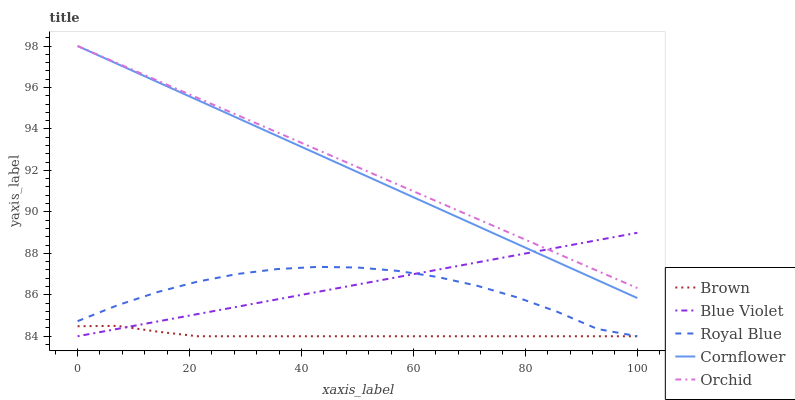Does Brown have the minimum area under the curve?
Answer yes or no. Yes. Does Orchid have the maximum area under the curve?
Answer yes or no. Yes. Does Cornflower have the minimum area under the curve?
Answer yes or no. No. Does Cornflower have the maximum area under the curve?
Answer yes or no. No. Is Blue Violet the smoothest?
Answer yes or no. Yes. Is Royal Blue the roughest?
Answer yes or no. Yes. Is Orchid the smoothest?
Answer yes or no. No. Is Orchid the roughest?
Answer yes or no. No. Does Brown have the lowest value?
Answer yes or no. Yes. Does Cornflower have the lowest value?
Answer yes or no. No. Does Cornflower have the highest value?
Answer yes or no. Yes. Does Blue Violet have the highest value?
Answer yes or no. No. Is Brown less than Orchid?
Answer yes or no. Yes. Is Orchid greater than Brown?
Answer yes or no. Yes. Does Cornflower intersect Blue Violet?
Answer yes or no. Yes. Is Cornflower less than Blue Violet?
Answer yes or no. No. Is Cornflower greater than Blue Violet?
Answer yes or no. No. Does Brown intersect Orchid?
Answer yes or no. No. 